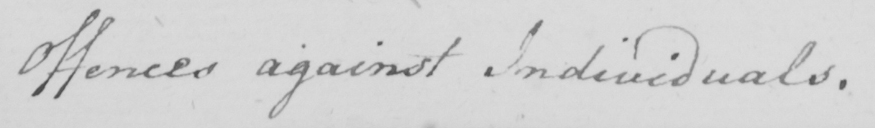What text is written in this handwritten line? Offences against Individuals . 